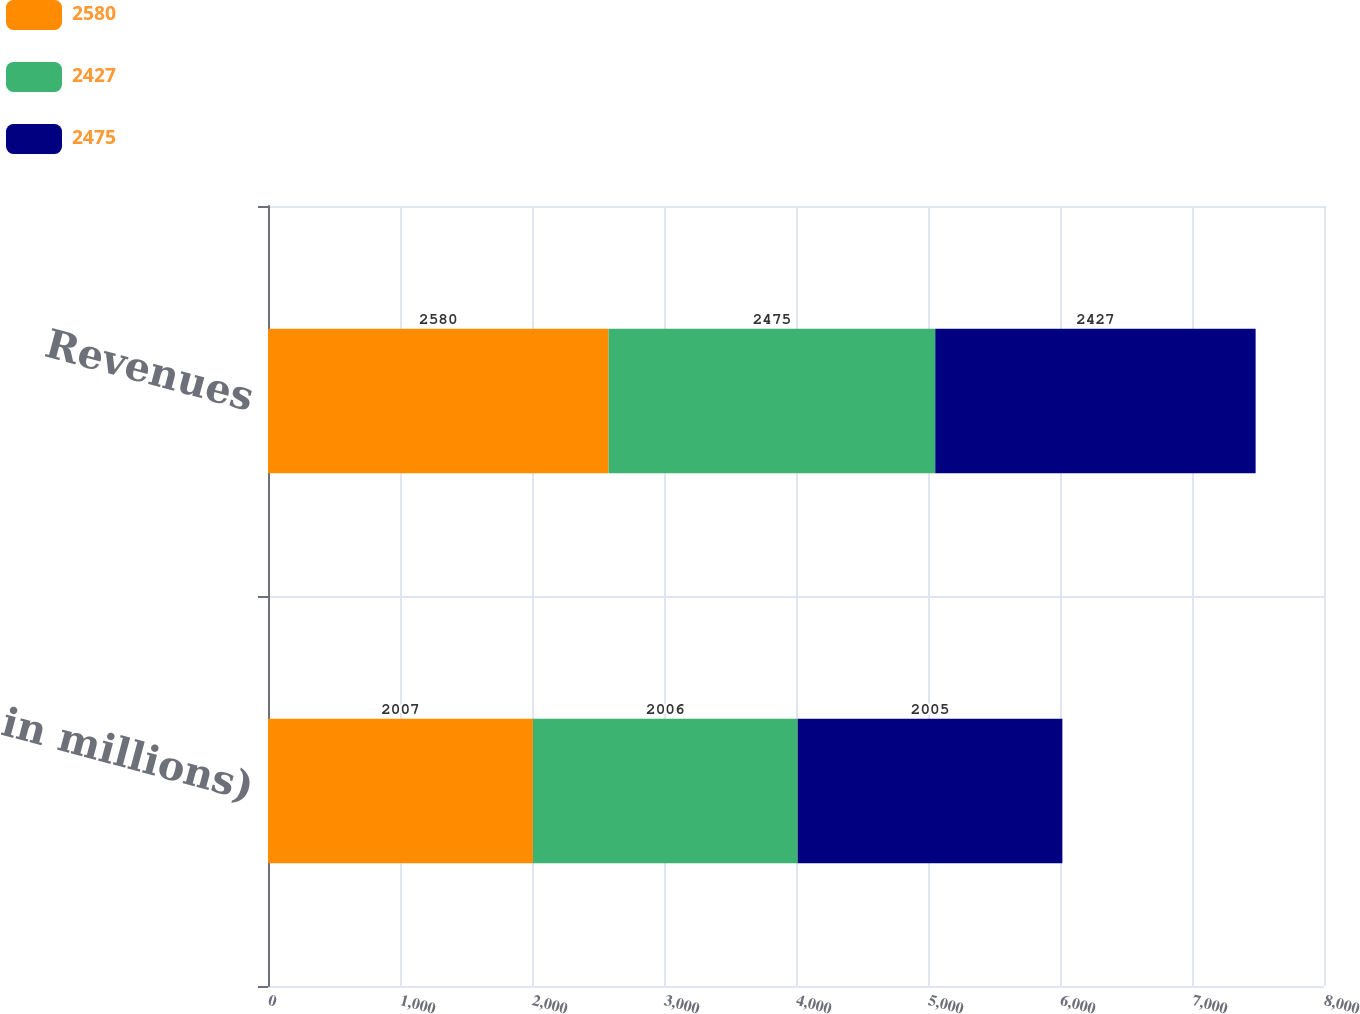Convert chart to OTSL. <chart><loc_0><loc_0><loc_500><loc_500><stacked_bar_chart><ecel><fcel>( in millions)<fcel>Revenues<nl><fcel>2580<fcel>2007<fcel>2580<nl><fcel>2427<fcel>2006<fcel>2475<nl><fcel>2475<fcel>2005<fcel>2427<nl></chart> 